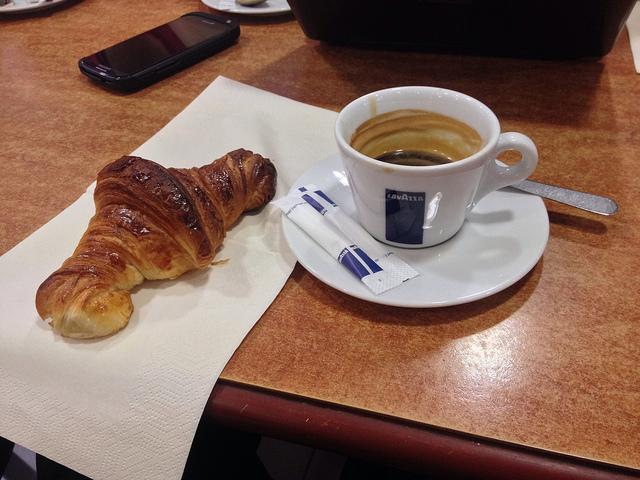What color is the block in the middle of the cup on the right?

Choices:
A) purple
B) green
C) blue
D) red blue 